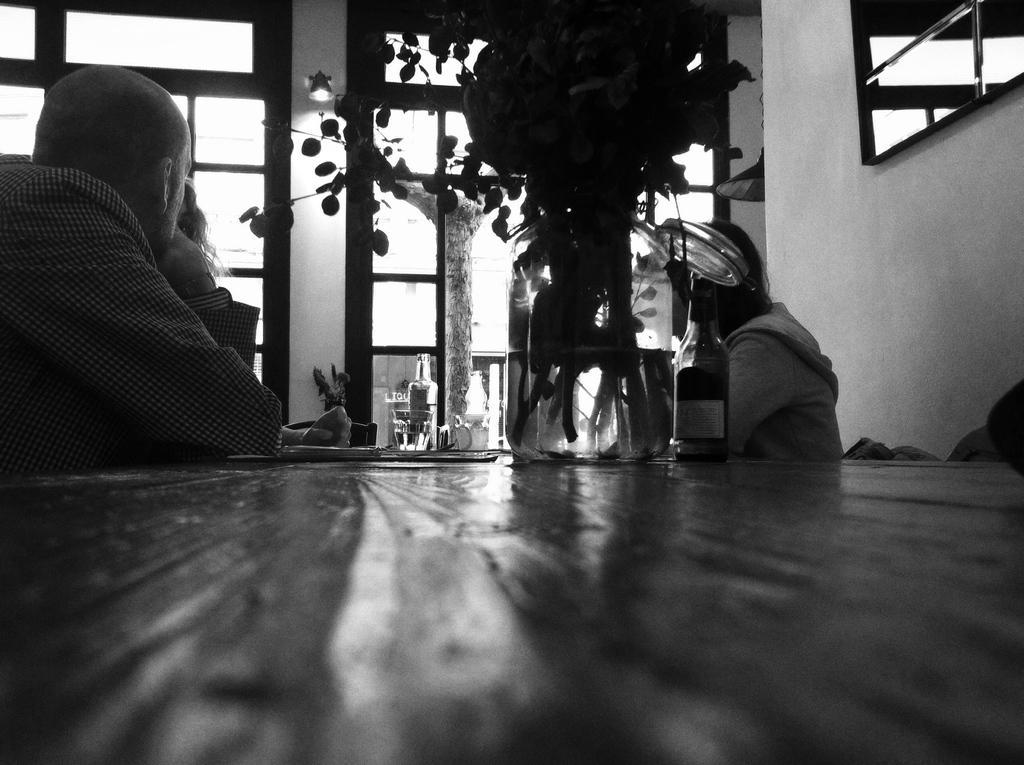Could you give a brief overview of what you see in this image? In the image there is a man sitting on the left is staring at the window. At the bottom of the image there is a table and there are bottles, glasses and a flower vase which is placed on a table. On the left there is a lady sitting. In the background we can see a tree and windows. 